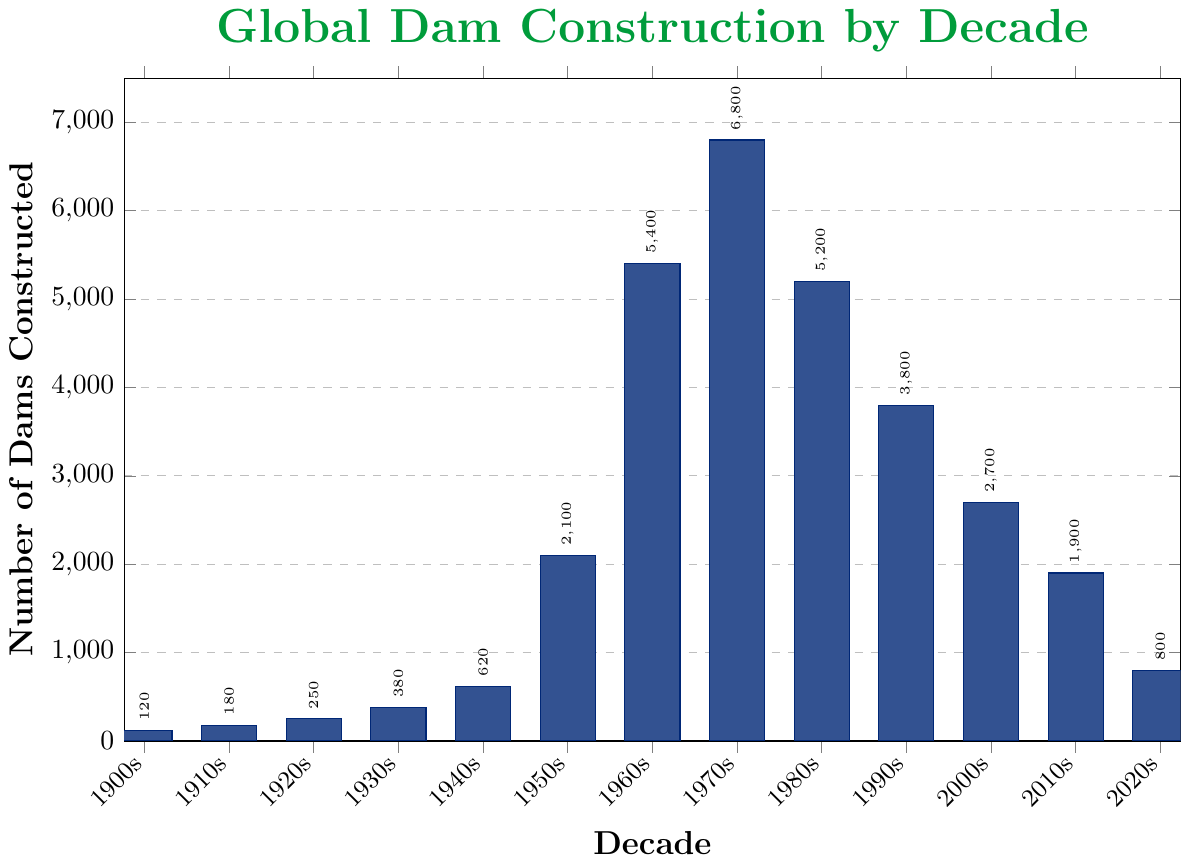Which decade saw the highest number of dams constructed? To find the decade with the highest number of dams constructed, we look for the tallest bar in the chart. The 1970s bar is the highest, indicating 6800 dams were constructed during this period.
Answer: 1970s How many more dams were constructed in the 1970s compared to the 1960s? Subtract the number of dams constructed in the 1960s (5400) from the number constructed in the 1970s (6800): 6800 - 5400 = 1400.
Answer: 1400 In which decade did the number of dams constructed first exceed 2000? Observing the height of each bar, the 1950s bar is the first to exceed the 2000 mark, with 2100 dams constructed.
Answer: 1950s What's the average number of dams constructed per decade from 1900 to 1949? Sum the number of dams from 1900-1909 (120), 1910-1919 (180), 1920-1929 (250), 1930-1939 (380), and 1940-1949 (620) which gives 1550. Divide this by the number of decades (5): 1550 / 5 = 310.
Answer: 310 By how much did the number of dams constructed decrease from the 1980s to the 2010s? Subtract the number of dams constructed in the 2010s (1900) from those in the 1980s (5200): 5200 - 1900 = 3300.
Answer: 3300 Which decades show a decreasing trend in the number of dams constructed? Identify consecutive decades where the height of each subsequent bar is lower than the previous: 1970s (6800) to 1980s (5200), 1980s to 1990s (3800), 1990s to 2000s (2700), 2000s to 2010s (1900), and 2010s to 2020s (800).
Answer: 1970s, 1980s, 1990s, 2000s, 2010s Which decades show an increasing trend in the number of dams constructed? Identify consecutive decades where the height of each subsequent bar is higher than the previous: 1900s (120) to 1910s (180), 1910s to 1920s (250), 1920s to 1930s (380), 1930s to 1940s (620), 1940s to 1950s (2100), 1950s to 1960s (5400), and 1960s to 1970s (6800).
Answer: 1900s, 1910s, 1920s, 1930s, 1940s, 1950s, 1960s What percentage of the total dams were constructed before 1950? Sum the number of dams constructed before 1950: 120 (1900s) + 180 (1910s) + 250 (1920s) + 380 (1930s) + 620 (1940s) = 1550. Sum the total number of dams: 1550 (pre-1950) + 2100 (1950s) + 5400 (1960s) + 6800 (1970s) + 5200 (1980s) + 3800 (1990s) + 2700 (2000s) + 1900 (2010s) + 800 (2020s) = 30250. Calculate the percentage: (1550 / 30250) * 100 ≈ 5.12%.
Answer: 5.12% 